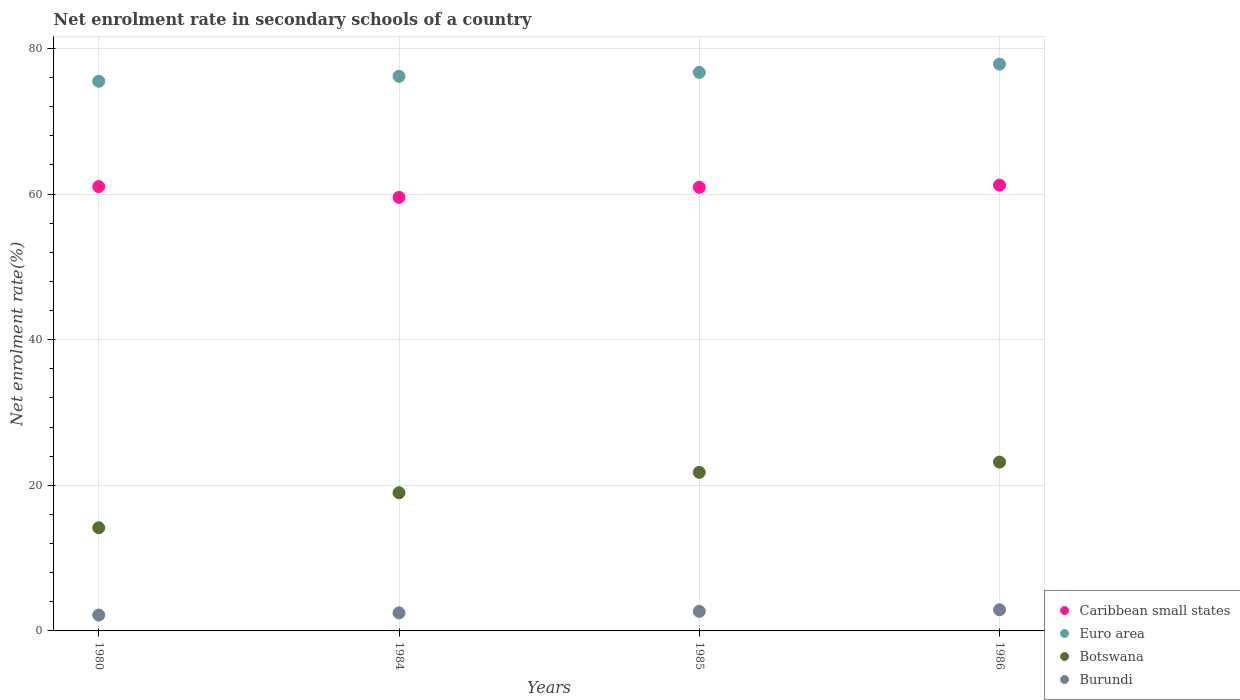Is the number of dotlines equal to the number of legend labels?
Your answer should be very brief. Yes. What is the net enrolment rate in secondary schools in Botswana in 1986?
Provide a short and direct response. 23.19. Across all years, what is the maximum net enrolment rate in secondary schools in Burundi?
Your answer should be very brief. 2.9. Across all years, what is the minimum net enrolment rate in secondary schools in Caribbean small states?
Ensure brevity in your answer.  59.55. What is the total net enrolment rate in secondary schools in Euro area in the graph?
Your answer should be compact. 306.24. What is the difference between the net enrolment rate in secondary schools in Botswana in 1980 and that in 1984?
Provide a short and direct response. -4.81. What is the difference between the net enrolment rate in secondary schools in Caribbean small states in 1984 and the net enrolment rate in secondary schools in Burundi in 1980?
Your answer should be very brief. 57.37. What is the average net enrolment rate in secondary schools in Burundi per year?
Provide a short and direct response. 2.56. In the year 1985, what is the difference between the net enrolment rate in secondary schools in Caribbean small states and net enrolment rate in secondary schools in Burundi?
Ensure brevity in your answer.  58.25. In how many years, is the net enrolment rate in secondary schools in Euro area greater than 36 %?
Ensure brevity in your answer.  4. What is the ratio of the net enrolment rate in secondary schools in Botswana in 1980 to that in 1984?
Keep it short and to the point. 0.75. What is the difference between the highest and the second highest net enrolment rate in secondary schools in Botswana?
Provide a short and direct response. 1.41. What is the difference between the highest and the lowest net enrolment rate in secondary schools in Burundi?
Offer a very short reply. 0.72. Is the sum of the net enrolment rate in secondary schools in Botswana in 1984 and 1986 greater than the maximum net enrolment rate in secondary schools in Euro area across all years?
Give a very brief answer. No. Does the net enrolment rate in secondary schools in Euro area monotonically increase over the years?
Your answer should be very brief. Yes. Is the net enrolment rate in secondary schools in Caribbean small states strictly less than the net enrolment rate in secondary schools in Botswana over the years?
Your response must be concise. No. How many dotlines are there?
Make the answer very short. 4. How many years are there in the graph?
Your answer should be compact. 4. What is the difference between two consecutive major ticks on the Y-axis?
Offer a terse response. 20. Does the graph contain grids?
Make the answer very short. Yes. How many legend labels are there?
Make the answer very short. 4. How are the legend labels stacked?
Make the answer very short. Vertical. What is the title of the graph?
Your answer should be compact. Net enrolment rate in secondary schools of a country. What is the label or title of the Y-axis?
Your answer should be very brief. Net enrolment rate(%). What is the Net enrolment rate(%) of Caribbean small states in 1980?
Provide a succinct answer. 61.03. What is the Net enrolment rate(%) in Euro area in 1980?
Your response must be concise. 75.5. What is the Net enrolment rate(%) of Botswana in 1980?
Your response must be concise. 14.17. What is the Net enrolment rate(%) of Burundi in 1980?
Provide a succinct answer. 2.18. What is the Net enrolment rate(%) of Caribbean small states in 1984?
Keep it short and to the point. 59.55. What is the Net enrolment rate(%) of Euro area in 1984?
Provide a short and direct response. 76.18. What is the Net enrolment rate(%) in Botswana in 1984?
Offer a terse response. 18.98. What is the Net enrolment rate(%) of Burundi in 1984?
Ensure brevity in your answer.  2.48. What is the Net enrolment rate(%) in Caribbean small states in 1985?
Offer a very short reply. 60.93. What is the Net enrolment rate(%) in Euro area in 1985?
Ensure brevity in your answer.  76.71. What is the Net enrolment rate(%) in Botswana in 1985?
Your response must be concise. 21.78. What is the Net enrolment rate(%) of Burundi in 1985?
Your answer should be compact. 2.69. What is the Net enrolment rate(%) in Caribbean small states in 1986?
Give a very brief answer. 61.23. What is the Net enrolment rate(%) in Euro area in 1986?
Your answer should be compact. 77.85. What is the Net enrolment rate(%) of Botswana in 1986?
Ensure brevity in your answer.  23.19. What is the Net enrolment rate(%) of Burundi in 1986?
Provide a succinct answer. 2.9. Across all years, what is the maximum Net enrolment rate(%) in Caribbean small states?
Your answer should be very brief. 61.23. Across all years, what is the maximum Net enrolment rate(%) in Euro area?
Offer a very short reply. 77.85. Across all years, what is the maximum Net enrolment rate(%) in Botswana?
Ensure brevity in your answer.  23.19. Across all years, what is the maximum Net enrolment rate(%) in Burundi?
Give a very brief answer. 2.9. Across all years, what is the minimum Net enrolment rate(%) in Caribbean small states?
Keep it short and to the point. 59.55. Across all years, what is the minimum Net enrolment rate(%) of Euro area?
Make the answer very short. 75.5. Across all years, what is the minimum Net enrolment rate(%) in Botswana?
Your answer should be very brief. 14.17. Across all years, what is the minimum Net enrolment rate(%) of Burundi?
Offer a terse response. 2.18. What is the total Net enrolment rate(%) in Caribbean small states in the graph?
Your response must be concise. 242.74. What is the total Net enrolment rate(%) in Euro area in the graph?
Ensure brevity in your answer.  306.24. What is the total Net enrolment rate(%) of Botswana in the graph?
Provide a succinct answer. 78.12. What is the total Net enrolment rate(%) of Burundi in the graph?
Ensure brevity in your answer.  10.25. What is the difference between the Net enrolment rate(%) of Caribbean small states in 1980 and that in 1984?
Offer a terse response. 1.48. What is the difference between the Net enrolment rate(%) in Euro area in 1980 and that in 1984?
Make the answer very short. -0.68. What is the difference between the Net enrolment rate(%) of Botswana in 1980 and that in 1984?
Provide a short and direct response. -4.81. What is the difference between the Net enrolment rate(%) in Burundi in 1980 and that in 1984?
Offer a very short reply. -0.3. What is the difference between the Net enrolment rate(%) of Caribbean small states in 1980 and that in 1985?
Provide a short and direct response. 0.1. What is the difference between the Net enrolment rate(%) in Euro area in 1980 and that in 1985?
Provide a short and direct response. -1.21. What is the difference between the Net enrolment rate(%) of Botswana in 1980 and that in 1985?
Offer a terse response. -7.61. What is the difference between the Net enrolment rate(%) in Burundi in 1980 and that in 1985?
Your response must be concise. -0.51. What is the difference between the Net enrolment rate(%) of Caribbean small states in 1980 and that in 1986?
Your answer should be compact. -0.2. What is the difference between the Net enrolment rate(%) in Euro area in 1980 and that in 1986?
Provide a succinct answer. -2.35. What is the difference between the Net enrolment rate(%) in Botswana in 1980 and that in 1986?
Provide a short and direct response. -9.01. What is the difference between the Net enrolment rate(%) of Burundi in 1980 and that in 1986?
Provide a succinct answer. -0.72. What is the difference between the Net enrolment rate(%) of Caribbean small states in 1984 and that in 1985?
Make the answer very short. -1.38. What is the difference between the Net enrolment rate(%) in Euro area in 1984 and that in 1985?
Offer a terse response. -0.54. What is the difference between the Net enrolment rate(%) in Botswana in 1984 and that in 1985?
Provide a short and direct response. -2.8. What is the difference between the Net enrolment rate(%) of Burundi in 1984 and that in 1985?
Offer a very short reply. -0.21. What is the difference between the Net enrolment rate(%) of Caribbean small states in 1984 and that in 1986?
Provide a succinct answer. -1.68. What is the difference between the Net enrolment rate(%) in Euro area in 1984 and that in 1986?
Keep it short and to the point. -1.67. What is the difference between the Net enrolment rate(%) of Botswana in 1984 and that in 1986?
Your answer should be very brief. -4.21. What is the difference between the Net enrolment rate(%) in Burundi in 1984 and that in 1986?
Offer a terse response. -0.43. What is the difference between the Net enrolment rate(%) of Caribbean small states in 1985 and that in 1986?
Offer a terse response. -0.3. What is the difference between the Net enrolment rate(%) of Euro area in 1985 and that in 1986?
Give a very brief answer. -1.14. What is the difference between the Net enrolment rate(%) in Botswana in 1985 and that in 1986?
Provide a succinct answer. -1.41. What is the difference between the Net enrolment rate(%) of Burundi in 1985 and that in 1986?
Make the answer very short. -0.22. What is the difference between the Net enrolment rate(%) of Caribbean small states in 1980 and the Net enrolment rate(%) of Euro area in 1984?
Make the answer very short. -15.15. What is the difference between the Net enrolment rate(%) in Caribbean small states in 1980 and the Net enrolment rate(%) in Botswana in 1984?
Your answer should be compact. 42.05. What is the difference between the Net enrolment rate(%) of Caribbean small states in 1980 and the Net enrolment rate(%) of Burundi in 1984?
Keep it short and to the point. 58.55. What is the difference between the Net enrolment rate(%) of Euro area in 1980 and the Net enrolment rate(%) of Botswana in 1984?
Give a very brief answer. 56.52. What is the difference between the Net enrolment rate(%) in Euro area in 1980 and the Net enrolment rate(%) in Burundi in 1984?
Your response must be concise. 73.02. What is the difference between the Net enrolment rate(%) in Botswana in 1980 and the Net enrolment rate(%) in Burundi in 1984?
Provide a short and direct response. 11.7. What is the difference between the Net enrolment rate(%) of Caribbean small states in 1980 and the Net enrolment rate(%) of Euro area in 1985?
Make the answer very short. -15.68. What is the difference between the Net enrolment rate(%) of Caribbean small states in 1980 and the Net enrolment rate(%) of Botswana in 1985?
Keep it short and to the point. 39.25. What is the difference between the Net enrolment rate(%) in Caribbean small states in 1980 and the Net enrolment rate(%) in Burundi in 1985?
Offer a terse response. 58.34. What is the difference between the Net enrolment rate(%) in Euro area in 1980 and the Net enrolment rate(%) in Botswana in 1985?
Give a very brief answer. 53.72. What is the difference between the Net enrolment rate(%) in Euro area in 1980 and the Net enrolment rate(%) in Burundi in 1985?
Ensure brevity in your answer.  72.81. What is the difference between the Net enrolment rate(%) in Botswana in 1980 and the Net enrolment rate(%) in Burundi in 1985?
Your answer should be very brief. 11.49. What is the difference between the Net enrolment rate(%) in Caribbean small states in 1980 and the Net enrolment rate(%) in Euro area in 1986?
Give a very brief answer. -16.82. What is the difference between the Net enrolment rate(%) of Caribbean small states in 1980 and the Net enrolment rate(%) of Botswana in 1986?
Your answer should be very brief. 37.84. What is the difference between the Net enrolment rate(%) in Caribbean small states in 1980 and the Net enrolment rate(%) in Burundi in 1986?
Your response must be concise. 58.13. What is the difference between the Net enrolment rate(%) in Euro area in 1980 and the Net enrolment rate(%) in Botswana in 1986?
Provide a short and direct response. 52.31. What is the difference between the Net enrolment rate(%) of Euro area in 1980 and the Net enrolment rate(%) of Burundi in 1986?
Provide a succinct answer. 72.59. What is the difference between the Net enrolment rate(%) of Botswana in 1980 and the Net enrolment rate(%) of Burundi in 1986?
Offer a terse response. 11.27. What is the difference between the Net enrolment rate(%) in Caribbean small states in 1984 and the Net enrolment rate(%) in Euro area in 1985?
Provide a succinct answer. -17.16. What is the difference between the Net enrolment rate(%) in Caribbean small states in 1984 and the Net enrolment rate(%) in Botswana in 1985?
Give a very brief answer. 37.77. What is the difference between the Net enrolment rate(%) of Caribbean small states in 1984 and the Net enrolment rate(%) of Burundi in 1985?
Your answer should be compact. 56.86. What is the difference between the Net enrolment rate(%) of Euro area in 1984 and the Net enrolment rate(%) of Botswana in 1985?
Your answer should be very brief. 54.4. What is the difference between the Net enrolment rate(%) of Euro area in 1984 and the Net enrolment rate(%) of Burundi in 1985?
Keep it short and to the point. 73.49. What is the difference between the Net enrolment rate(%) in Botswana in 1984 and the Net enrolment rate(%) in Burundi in 1985?
Offer a terse response. 16.29. What is the difference between the Net enrolment rate(%) in Caribbean small states in 1984 and the Net enrolment rate(%) in Euro area in 1986?
Offer a terse response. -18.3. What is the difference between the Net enrolment rate(%) of Caribbean small states in 1984 and the Net enrolment rate(%) of Botswana in 1986?
Your response must be concise. 36.36. What is the difference between the Net enrolment rate(%) in Caribbean small states in 1984 and the Net enrolment rate(%) in Burundi in 1986?
Provide a short and direct response. 56.65. What is the difference between the Net enrolment rate(%) of Euro area in 1984 and the Net enrolment rate(%) of Botswana in 1986?
Provide a short and direct response. 52.99. What is the difference between the Net enrolment rate(%) in Euro area in 1984 and the Net enrolment rate(%) in Burundi in 1986?
Make the answer very short. 73.27. What is the difference between the Net enrolment rate(%) in Botswana in 1984 and the Net enrolment rate(%) in Burundi in 1986?
Ensure brevity in your answer.  16.07. What is the difference between the Net enrolment rate(%) of Caribbean small states in 1985 and the Net enrolment rate(%) of Euro area in 1986?
Offer a very short reply. -16.92. What is the difference between the Net enrolment rate(%) of Caribbean small states in 1985 and the Net enrolment rate(%) of Botswana in 1986?
Keep it short and to the point. 37.75. What is the difference between the Net enrolment rate(%) of Caribbean small states in 1985 and the Net enrolment rate(%) of Burundi in 1986?
Keep it short and to the point. 58.03. What is the difference between the Net enrolment rate(%) of Euro area in 1985 and the Net enrolment rate(%) of Botswana in 1986?
Ensure brevity in your answer.  53.53. What is the difference between the Net enrolment rate(%) of Euro area in 1985 and the Net enrolment rate(%) of Burundi in 1986?
Your answer should be very brief. 73.81. What is the difference between the Net enrolment rate(%) in Botswana in 1985 and the Net enrolment rate(%) in Burundi in 1986?
Your answer should be compact. 18.87. What is the average Net enrolment rate(%) of Caribbean small states per year?
Keep it short and to the point. 60.69. What is the average Net enrolment rate(%) in Euro area per year?
Ensure brevity in your answer.  76.56. What is the average Net enrolment rate(%) of Botswana per year?
Ensure brevity in your answer.  19.53. What is the average Net enrolment rate(%) in Burundi per year?
Offer a terse response. 2.56. In the year 1980, what is the difference between the Net enrolment rate(%) of Caribbean small states and Net enrolment rate(%) of Euro area?
Your answer should be very brief. -14.47. In the year 1980, what is the difference between the Net enrolment rate(%) of Caribbean small states and Net enrolment rate(%) of Botswana?
Provide a succinct answer. 46.86. In the year 1980, what is the difference between the Net enrolment rate(%) of Caribbean small states and Net enrolment rate(%) of Burundi?
Ensure brevity in your answer.  58.85. In the year 1980, what is the difference between the Net enrolment rate(%) of Euro area and Net enrolment rate(%) of Botswana?
Your answer should be compact. 61.33. In the year 1980, what is the difference between the Net enrolment rate(%) of Euro area and Net enrolment rate(%) of Burundi?
Your response must be concise. 73.32. In the year 1980, what is the difference between the Net enrolment rate(%) in Botswana and Net enrolment rate(%) in Burundi?
Make the answer very short. 11.99. In the year 1984, what is the difference between the Net enrolment rate(%) of Caribbean small states and Net enrolment rate(%) of Euro area?
Provide a short and direct response. -16.63. In the year 1984, what is the difference between the Net enrolment rate(%) of Caribbean small states and Net enrolment rate(%) of Botswana?
Make the answer very short. 40.57. In the year 1984, what is the difference between the Net enrolment rate(%) in Caribbean small states and Net enrolment rate(%) in Burundi?
Keep it short and to the point. 57.07. In the year 1984, what is the difference between the Net enrolment rate(%) in Euro area and Net enrolment rate(%) in Botswana?
Offer a terse response. 57.2. In the year 1984, what is the difference between the Net enrolment rate(%) in Euro area and Net enrolment rate(%) in Burundi?
Your answer should be very brief. 73.7. In the year 1984, what is the difference between the Net enrolment rate(%) in Botswana and Net enrolment rate(%) in Burundi?
Your answer should be very brief. 16.5. In the year 1985, what is the difference between the Net enrolment rate(%) in Caribbean small states and Net enrolment rate(%) in Euro area?
Offer a terse response. -15.78. In the year 1985, what is the difference between the Net enrolment rate(%) of Caribbean small states and Net enrolment rate(%) of Botswana?
Your response must be concise. 39.15. In the year 1985, what is the difference between the Net enrolment rate(%) in Caribbean small states and Net enrolment rate(%) in Burundi?
Ensure brevity in your answer.  58.25. In the year 1985, what is the difference between the Net enrolment rate(%) of Euro area and Net enrolment rate(%) of Botswana?
Keep it short and to the point. 54.93. In the year 1985, what is the difference between the Net enrolment rate(%) of Euro area and Net enrolment rate(%) of Burundi?
Keep it short and to the point. 74.03. In the year 1985, what is the difference between the Net enrolment rate(%) of Botswana and Net enrolment rate(%) of Burundi?
Your answer should be very brief. 19.09. In the year 1986, what is the difference between the Net enrolment rate(%) in Caribbean small states and Net enrolment rate(%) in Euro area?
Provide a short and direct response. -16.62. In the year 1986, what is the difference between the Net enrolment rate(%) of Caribbean small states and Net enrolment rate(%) of Botswana?
Your response must be concise. 38.04. In the year 1986, what is the difference between the Net enrolment rate(%) of Caribbean small states and Net enrolment rate(%) of Burundi?
Make the answer very short. 58.32. In the year 1986, what is the difference between the Net enrolment rate(%) of Euro area and Net enrolment rate(%) of Botswana?
Offer a very short reply. 54.66. In the year 1986, what is the difference between the Net enrolment rate(%) of Euro area and Net enrolment rate(%) of Burundi?
Give a very brief answer. 74.95. In the year 1986, what is the difference between the Net enrolment rate(%) of Botswana and Net enrolment rate(%) of Burundi?
Offer a terse response. 20.28. What is the ratio of the Net enrolment rate(%) in Caribbean small states in 1980 to that in 1984?
Offer a terse response. 1.02. What is the ratio of the Net enrolment rate(%) in Botswana in 1980 to that in 1984?
Your answer should be very brief. 0.75. What is the ratio of the Net enrolment rate(%) of Burundi in 1980 to that in 1984?
Your answer should be compact. 0.88. What is the ratio of the Net enrolment rate(%) in Caribbean small states in 1980 to that in 1985?
Provide a succinct answer. 1. What is the ratio of the Net enrolment rate(%) of Euro area in 1980 to that in 1985?
Offer a terse response. 0.98. What is the ratio of the Net enrolment rate(%) of Botswana in 1980 to that in 1985?
Provide a short and direct response. 0.65. What is the ratio of the Net enrolment rate(%) of Burundi in 1980 to that in 1985?
Offer a terse response. 0.81. What is the ratio of the Net enrolment rate(%) in Euro area in 1980 to that in 1986?
Offer a terse response. 0.97. What is the ratio of the Net enrolment rate(%) in Botswana in 1980 to that in 1986?
Give a very brief answer. 0.61. What is the ratio of the Net enrolment rate(%) in Burundi in 1980 to that in 1986?
Ensure brevity in your answer.  0.75. What is the ratio of the Net enrolment rate(%) in Caribbean small states in 1984 to that in 1985?
Keep it short and to the point. 0.98. What is the ratio of the Net enrolment rate(%) in Botswana in 1984 to that in 1985?
Provide a succinct answer. 0.87. What is the ratio of the Net enrolment rate(%) of Burundi in 1984 to that in 1985?
Ensure brevity in your answer.  0.92. What is the ratio of the Net enrolment rate(%) in Caribbean small states in 1984 to that in 1986?
Your answer should be compact. 0.97. What is the ratio of the Net enrolment rate(%) in Euro area in 1984 to that in 1986?
Provide a succinct answer. 0.98. What is the ratio of the Net enrolment rate(%) of Botswana in 1984 to that in 1986?
Make the answer very short. 0.82. What is the ratio of the Net enrolment rate(%) in Burundi in 1984 to that in 1986?
Provide a short and direct response. 0.85. What is the ratio of the Net enrolment rate(%) of Euro area in 1985 to that in 1986?
Give a very brief answer. 0.99. What is the ratio of the Net enrolment rate(%) of Botswana in 1985 to that in 1986?
Your answer should be compact. 0.94. What is the ratio of the Net enrolment rate(%) of Burundi in 1985 to that in 1986?
Give a very brief answer. 0.93. What is the difference between the highest and the second highest Net enrolment rate(%) of Caribbean small states?
Give a very brief answer. 0.2. What is the difference between the highest and the second highest Net enrolment rate(%) of Euro area?
Your answer should be compact. 1.14. What is the difference between the highest and the second highest Net enrolment rate(%) of Botswana?
Offer a very short reply. 1.41. What is the difference between the highest and the second highest Net enrolment rate(%) of Burundi?
Your answer should be compact. 0.22. What is the difference between the highest and the lowest Net enrolment rate(%) of Caribbean small states?
Give a very brief answer. 1.68. What is the difference between the highest and the lowest Net enrolment rate(%) of Euro area?
Ensure brevity in your answer.  2.35. What is the difference between the highest and the lowest Net enrolment rate(%) in Botswana?
Your response must be concise. 9.01. What is the difference between the highest and the lowest Net enrolment rate(%) in Burundi?
Your answer should be very brief. 0.72. 